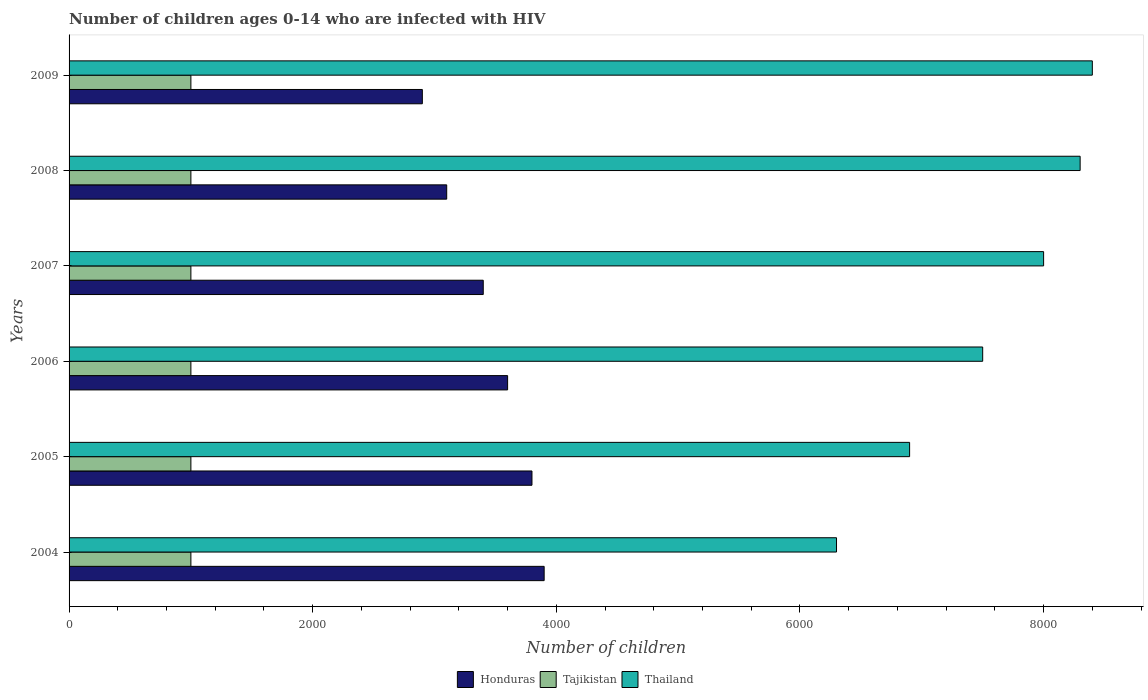Are the number of bars on each tick of the Y-axis equal?
Your response must be concise. Yes. How many bars are there on the 4th tick from the bottom?
Your answer should be very brief. 3. What is the label of the 2nd group of bars from the top?
Your answer should be very brief. 2008. What is the number of HIV infected children in Honduras in 2005?
Offer a very short reply. 3800. Across all years, what is the maximum number of HIV infected children in Thailand?
Provide a succinct answer. 8400. Across all years, what is the minimum number of HIV infected children in Thailand?
Your answer should be very brief. 6300. In which year was the number of HIV infected children in Thailand maximum?
Give a very brief answer. 2009. In which year was the number of HIV infected children in Tajikistan minimum?
Make the answer very short. 2004. What is the total number of HIV infected children in Thailand in the graph?
Your response must be concise. 4.54e+04. What is the difference between the number of HIV infected children in Honduras in 2006 and that in 2009?
Make the answer very short. 700. What is the difference between the number of HIV infected children in Thailand in 2009 and the number of HIV infected children in Tajikistan in 2007?
Provide a succinct answer. 7400. What is the average number of HIV infected children in Thailand per year?
Offer a very short reply. 7566.67. In the year 2006, what is the difference between the number of HIV infected children in Thailand and number of HIV infected children in Tajikistan?
Your response must be concise. 6500. Is the number of HIV infected children in Thailand in 2005 less than that in 2008?
Offer a very short reply. Yes. Is the difference between the number of HIV infected children in Thailand in 2006 and 2009 greater than the difference between the number of HIV infected children in Tajikistan in 2006 and 2009?
Offer a very short reply. No. What is the difference between the highest and the lowest number of HIV infected children in Tajikistan?
Give a very brief answer. 0. Is the sum of the number of HIV infected children in Honduras in 2004 and 2005 greater than the maximum number of HIV infected children in Thailand across all years?
Ensure brevity in your answer.  No. What does the 3rd bar from the top in 2009 represents?
Your response must be concise. Honduras. What does the 1st bar from the bottom in 2009 represents?
Your response must be concise. Honduras. Is it the case that in every year, the sum of the number of HIV infected children in Honduras and number of HIV infected children in Thailand is greater than the number of HIV infected children in Tajikistan?
Your response must be concise. Yes. Are all the bars in the graph horizontal?
Ensure brevity in your answer.  Yes. What is the difference between two consecutive major ticks on the X-axis?
Your answer should be very brief. 2000. Does the graph contain any zero values?
Keep it short and to the point. No. Where does the legend appear in the graph?
Your response must be concise. Bottom center. What is the title of the graph?
Provide a short and direct response. Number of children ages 0-14 who are infected with HIV. Does "Venezuela" appear as one of the legend labels in the graph?
Your answer should be very brief. No. What is the label or title of the X-axis?
Ensure brevity in your answer.  Number of children. What is the label or title of the Y-axis?
Offer a terse response. Years. What is the Number of children in Honduras in 2004?
Provide a short and direct response. 3900. What is the Number of children in Thailand in 2004?
Offer a terse response. 6300. What is the Number of children in Honduras in 2005?
Offer a very short reply. 3800. What is the Number of children in Tajikistan in 2005?
Your answer should be compact. 1000. What is the Number of children of Thailand in 2005?
Ensure brevity in your answer.  6900. What is the Number of children in Honduras in 2006?
Ensure brevity in your answer.  3600. What is the Number of children of Tajikistan in 2006?
Give a very brief answer. 1000. What is the Number of children in Thailand in 2006?
Make the answer very short. 7500. What is the Number of children of Honduras in 2007?
Offer a very short reply. 3400. What is the Number of children of Thailand in 2007?
Keep it short and to the point. 8000. What is the Number of children in Honduras in 2008?
Provide a succinct answer. 3100. What is the Number of children in Tajikistan in 2008?
Keep it short and to the point. 1000. What is the Number of children of Thailand in 2008?
Your answer should be very brief. 8300. What is the Number of children in Honduras in 2009?
Provide a short and direct response. 2900. What is the Number of children in Thailand in 2009?
Your answer should be compact. 8400. Across all years, what is the maximum Number of children in Honduras?
Offer a terse response. 3900. Across all years, what is the maximum Number of children of Tajikistan?
Offer a terse response. 1000. Across all years, what is the maximum Number of children of Thailand?
Offer a very short reply. 8400. Across all years, what is the minimum Number of children in Honduras?
Provide a short and direct response. 2900. Across all years, what is the minimum Number of children of Thailand?
Offer a very short reply. 6300. What is the total Number of children of Honduras in the graph?
Give a very brief answer. 2.07e+04. What is the total Number of children of Tajikistan in the graph?
Keep it short and to the point. 6000. What is the total Number of children of Thailand in the graph?
Your answer should be compact. 4.54e+04. What is the difference between the Number of children of Honduras in 2004 and that in 2005?
Provide a short and direct response. 100. What is the difference between the Number of children of Thailand in 2004 and that in 2005?
Offer a very short reply. -600. What is the difference between the Number of children of Honduras in 2004 and that in 2006?
Your answer should be very brief. 300. What is the difference between the Number of children of Tajikistan in 2004 and that in 2006?
Your answer should be compact. 0. What is the difference between the Number of children in Thailand in 2004 and that in 2006?
Your response must be concise. -1200. What is the difference between the Number of children of Thailand in 2004 and that in 2007?
Provide a succinct answer. -1700. What is the difference between the Number of children of Honduras in 2004 and that in 2008?
Offer a terse response. 800. What is the difference between the Number of children of Tajikistan in 2004 and that in 2008?
Make the answer very short. 0. What is the difference between the Number of children in Thailand in 2004 and that in 2008?
Your response must be concise. -2000. What is the difference between the Number of children in Honduras in 2004 and that in 2009?
Offer a very short reply. 1000. What is the difference between the Number of children in Thailand in 2004 and that in 2009?
Provide a succinct answer. -2100. What is the difference between the Number of children in Tajikistan in 2005 and that in 2006?
Provide a short and direct response. 0. What is the difference between the Number of children in Thailand in 2005 and that in 2006?
Keep it short and to the point. -600. What is the difference between the Number of children of Honduras in 2005 and that in 2007?
Your response must be concise. 400. What is the difference between the Number of children in Tajikistan in 2005 and that in 2007?
Offer a very short reply. 0. What is the difference between the Number of children of Thailand in 2005 and that in 2007?
Your answer should be compact. -1100. What is the difference between the Number of children of Honduras in 2005 and that in 2008?
Provide a succinct answer. 700. What is the difference between the Number of children in Tajikistan in 2005 and that in 2008?
Offer a very short reply. 0. What is the difference between the Number of children of Thailand in 2005 and that in 2008?
Offer a very short reply. -1400. What is the difference between the Number of children of Honduras in 2005 and that in 2009?
Keep it short and to the point. 900. What is the difference between the Number of children of Thailand in 2005 and that in 2009?
Your answer should be compact. -1500. What is the difference between the Number of children in Tajikistan in 2006 and that in 2007?
Keep it short and to the point. 0. What is the difference between the Number of children of Thailand in 2006 and that in 2007?
Give a very brief answer. -500. What is the difference between the Number of children of Tajikistan in 2006 and that in 2008?
Offer a terse response. 0. What is the difference between the Number of children in Thailand in 2006 and that in 2008?
Give a very brief answer. -800. What is the difference between the Number of children in Honduras in 2006 and that in 2009?
Your answer should be very brief. 700. What is the difference between the Number of children of Thailand in 2006 and that in 2009?
Give a very brief answer. -900. What is the difference between the Number of children in Honduras in 2007 and that in 2008?
Your response must be concise. 300. What is the difference between the Number of children in Tajikistan in 2007 and that in 2008?
Offer a terse response. 0. What is the difference between the Number of children of Thailand in 2007 and that in 2008?
Your answer should be compact. -300. What is the difference between the Number of children in Honduras in 2007 and that in 2009?
Make the answer very short. 500. What is the difference between the Number of children of Thailand in 2007 and that in 2009?
Keep it short and to the point. -400. What is the difference between the Number of children of Honduras in 2008 and that in 2009?
Offer a terse response. 200. What is the difference between the Number of children of Thailand in 2008 and that in 2009?
Ensure brevity in your answer.  -100. What is the difference between the Number of children of Honduras in 2004 and the Number of children of Tajikistan in 2005?
Provide a succinct answer. 2900. What is the difference between the Number of children in Honduras in 2004 and the Number of children in Thailand in 2005?
Give a very brief answer. -3000. What is the difference between the Number of children of Tajikistan in 2004 and the Number of children of Thailand in 2005?
Keep it short and to the point. -5900. What is the difference between the Number of children of Honduras in 2004 and the Number of children of Tajikistan in 2006?
Keep it short and to the point. 2900. What is the difference between the Number of children in Honduras in 2004 and the Number of children in Thailand in 2006?
Ensure brevity in your answer.  -3600. What is the difference between the Number of children of Tajikistan in 2004 and the Number of children of Thailand in 2006?
Offer a very short reply. -6500. What is the difference between the Number of children in Honduras in 2004 and the Number of children in Tajikistan in 2007?
Make the answer very short. 2900. What is the difference between the Number of children of Honduras in 2004 and the Number of children of Thailand in 2007?
Your answer should be compact. -4100. What is the difference between the Number of children in Tajikistan in 2004 and the Number of children in Thailand in 2007?
Ensure brevity in your answer.  -7000. What is the difference between the Number of children in Honduras in 2004 and the Number of children in Tajikistan in 2008?
Your answer should be compact. 2900. What is the difference between the Number of children of Honduras in 2004 and the Number of children of Thailand in 2008?
Offer a terse response. -4400. What is the difference between the Number of children in Tajikistan in 2004 and the Number of children in Thailand in 2008?
Offer a terse response. -7300. What is the difference between the Number of children of Honduras in 2004 and the Number of children of Tajikistan in 2009?
Your response must be concise. 2900. What is the difference between the Number of children of Honduras in 2004 and the Number of children of Thailand in 2009?
Keep it short and to the point. -4500. What is the difference between the Number of children of Tajikistan in 2004 and the Number of children of Thailand in 2009?
Your response must be concise. -7400. What is the difference between the Number of children in Honduras in 2005 and the Number of children in Tajikistan in 2006?
Your answer should be very brief. 2800. What is the difference between the Number of children in Honduras in 2005 and the Number of children in Thailand in 2006?
Provide a short and direct response. -3700. What is the difference between the Number of children of Tajikistan in 2005 and the Number of children of Thailand in 2006?
Make the answer very short. -6500. What is the difference between the Number of children in Honduras in 2005 and the Number of children in Tajikistan in 2007?
Your response must be concise. 2800. What is the difference between the Number of children in Honduras in 2005 and the Number of children in Thailand in 2007?
Your response must be concise. -4200. What is the difference between the Number of children in Tajikistan in 2005 and the Number of children in Thailand in 2007?
Give a very brief answer. -7000. What is the difference between the Number of children of Honduras in 2005 and the Number of children of Tajikistan in 2008?
Offer a terse response. 2800. What is the difference between the Number of children in Honduras in 2005 and the Number of children in Thailand in 2008?
Make the answer very short. -4500. What is the difference between the Number of children of Tajikistan in 2005 and the Number of children of Thailand in 2008?
Your answer should be compact. -7300. What is the difference between the Number of children of Honduras in 2005 and the Number of children of Tajikistan in 2009?
Offer a terse response. 2800. What is the difference between the Number of children of Honduras in 2005 and the Number of children of Thailand in 2009?
Your response must be concise. -4600. What is the difference between the Number of children in Tajikistan in 2005 and the Number of children in Thailand in 2009?
Your answer should be very brief. -7400. What is the difference between the Number of children of Honduras in 2006 and the Number of children of Tajikistan in 2007?
Your answer should be very brief. 2600. What is the difference between the Number of children in Honduras in 2006 and the Number of children in Thailand in 2007?
Your answer should be compact. -4400. What is the difference between the Number of children in Tajikistan in 2006 and the Number of children in Thailand in 2007?
Provide a short and direct response. -7000. What is the difference between the Number of children of Honduras in 2006 and the Number of children of Tajikistan in 2008?
Provide a short and direct response. 2600. What is the difference between the Number of children of Honduras in 2006 and the Number of children of Thailand in 2008?
Give a very brief answer. -4700. What is the difference between the Number of children in Tajikistan in 2006 and the Number of children in Thailand in 2008?
Provide a short and direct response. -7300. What is the difference between the Number of children of Honduras in 2006 and the Number of children of Tajikistan in 2009?
Make the answer very short. 2600. What is the difference between the Number of children in Honduras in 2006 and the Number of children in Thailand in 2009?
Offer a terse response. -4800. What is the difference between the Number of children of Tajikistan in 2006 and the Number of children of Thailand in 2009?
Your answer should be very brief. -7400. What is the difference between the Number of children of Honduras in 2007 and the Number of children of Tajikistan in 2008?
Your response must be concise. 2400. What is the difference between the Number of children of Honduras in 2007 and the Number of children of Thailand in 2008?
Ensure brevity in your answer.  -4900. What is the difference between the Number of children of Tajikistan in 2007 and the Number of children of Thailand in 2008?
Offer a very short reply. -7300. What is the difference between the Number of children in Honduras in 2007 and the Number of children in Tajikistan in 2009?
Your response must be concise. 2400. What is the difference between the Number of children in Honduras in 2007 and the Number of children in Thailand in 2009?
Offer a terse response. -5000. What is the difference between the Number of children of Tajikistan in 2007 and the Number of children of Thailand in 2009?
Give a very brief answer. -7400. What is the difference between the Number of children of Honduras in 2008 and the Number of children of Tajikistan in 2009?
Keep it short and to the point. 2100. What is the difference between the Number of children of Honduras in 2008 and the Number of children of Thailand in 2009?
Offer a very short reply. -5300. What is the difference between the Number of children in Tajikistan in 2008 and the Number of children in Thailand in 2009?
Make the answer very short. -7400. What is the average Number of children of Honduras per year?
Your answer should be compact. 3450. What is the average Number of children in Tajikistan per year?
Your response must be concise. 1000. What is the average Number of children of Thailand per year?
Your answer should be compact. 7566.67. In the year 2004, what is the difference between the Number of children in Honduras and Number of children in Tajikistan?
Give a very brief answer. 2900. In the year 2004, what is the difference between the Number of children of Honduras and Number of children of Thailand?
Make the answer very short. -2400. In the year 2004, what is the difference between the Number of children of Tajikistan and Number of children of Thailand?
Make the answer very short. -5300. In the year 2005, what is the difference between the Number of children of Honduras and Number of children of Tajikistan?
Your answer should be very brief. 2800. In the year 2005, what is the difference between the Number of children of Honduras and Number of children of Thailand?
Offer a very short reply. -3100. In the year 2005, what is the difference between the Number of children in Tajikistan and Number of children in Thailand?
Ensure brevity in your answer.  -5900. In the year 2006, what is the difference between the Number of children of Honduras and Number of children of Tajikistan?
Keep it short and to the point. 2600. In the year 2006, what is the difference between the Number of children of Honduras and Number of children of Thailand?
Give a very brief answer. -3900. In the year 2006, what is the difference between the Number of children in Tajikistan and Number of children in Thailand?
Offer a very short reply. -6500. In the year 2007, what is the difference between the Number of children of Honduras and Number of children of Tajikistan?
Make the answer very short. 2400. In the year 2007, what is the difference between the Number of children in Honduras and Number of children in Thailand?
Give a very brief answer. -4600. In the year 2007, what is the difference between the Number of children in Tajikistan and Number of children in Thailand?
Your answer should be very brief. -7000. In the year 2008, what is the difference between the Number of children in Honduras and Number of children in Tajikistan?
Your answer should be very brief. 2100. In the year 2008, what is the difference between the Number of children of Honduras and Number of children of Thailand?
Your answer should be very brief. -5200. In the year 2008, what is the difference between the Number of children of Tajikistan and Number of children of Thailand?
Offer a very short reply. -7300. In the year 2009, what is the difference between the Number of children of Honduras and Number of children of Tajikistan?
Your answer should be compact. 1900. In the year 2009, what is the difference between the Number of children in Honduras and Number of children in Thailand?
Your response must be concise. -5500. In the year 2009, what is the difference between the Number of children in Tajikistan and Number of children in Thailand?
Make the answer very short. -7400. What is the ratio of the Number of children in Honduras in 2004 to that in 2005?
Your answer should be very brief. 1.03. What is the ratio of the Number of children in Thailand in 2004 to that in 2005?
Offer a terse response. 0.91. What is the ratio of the Number of children in Tajikistan in 2004 to that in 2006?
Offer a terse response. 1. What is the ratio of the Number of children in Thailand in 2004 to that in 2006?
Make the answer very short. 0.84. What is the ratio of the Number of children of Honduras in 2004 to that in 2007?
Offer a terse response. 1.15. What is the ratio of the Number of children of Tajikistan in 2004 to that in 2007?
Keep it short and to the point. 1. What is the ratio of the Number of children of Thailand in 2004 to that in 2007?
Your answer should be very brief. 0.79. What is the ratio of the Number of children in Honduras in 2004 to that in 2008?
Make the answer very short. 1.26. What is the ratio of the Number of children of Thailand in 2004 to that in 2008?
Your answer should be very brief. 0.76. What is the ratio of the Number of children in Honduras in 2004 to that in 2009?
Provide a short and direct response. 1.34. What is the ratio of the Number of children of Honduras in 2005 to that in 2006?
Ensure brevity in your answer.  1.06. What is the ratio of the Number of children of Honduras in 2005 to that in 2007?
Your answer should be very brief. 1.12. What is the ratio of the Number of children of Thailand in 2005 to that in 2007?
Your answer should be compact. 0.86. What is the ratio of the Number of children of Honduras in 2005 to that in 2008?
Keep it short and to the point. 1.23. What is the ratio of the Number of children of Thailand in 2005 to that in 2008?
Provide a succinct answer. 0.83. What is the ratio of the Number of children of Honduras in 2005 to that in 2009?
Make the answer very short. 1.31. What is the ratio of the Number of children of Tajikistan in 2005 to that in 2009?
Your answer should be very brief. 1. What is the ratio of the Number of children of Thailand in 2005 to that in 2009?
Provide a short and direct response. 0.82. What is the ratio of the Number of children in Honduras in 2006 to that in 2007?
Offer a terse response. 1.06. What is the ratio of the Number of children in Tajikistan in 2006 to that in 2007?
Ensure brevity in your answer.  1. What is the ratio of the Number of children in Honduras in 2006 to that in 2008?
Offer a very short reply. 1.16. What is the ratio of the Number of children in Tajikistan in 2006 to that in 2008?
Give a very brief answer. 1. What is the ratio of the Number of children in Thailand in 2006 to that in 2008?
Keep it short and to the point. 0.9. What is the ratio of the Number of children of Honduras in 2006 to that in 2009?
Give a very brief answer. 1.24. What is the ratio of the Number of children in Thailand in 2006 to that in 2009?
Your answer should be compact. 0.89. What is the ratio of the Number of children in Honduras in 2007 to that in 2008?
Offer a terse response. 1.1. What is the ratio of the Number of children of Tajikistan in 2007 to that in 2008?
Your answer should be compact. 1. What is the ratio of the Number of children of Thailand in 2007 to that in 2008?
Offer a terse response. 0.96. What is the ratio of the Number of children of Honduras in 2007 to that in 2009?
Your response must be concise. 1.17. What is the ratio of the Number of children of Thailand in 2007 to that in 2009?
Keep it short and to the point. 0.95. What is the ratio of the Number of children of Honduras in 2008 to that in 2009?
Make the answer very short. 1.07. What is the difference between the highest and the second highest Number of children in Tajikistan?
Your answer should be compact. 0. What is the difference between the highest and the lowest Number of children of Thailand?
Offer a terse response. 2100. 